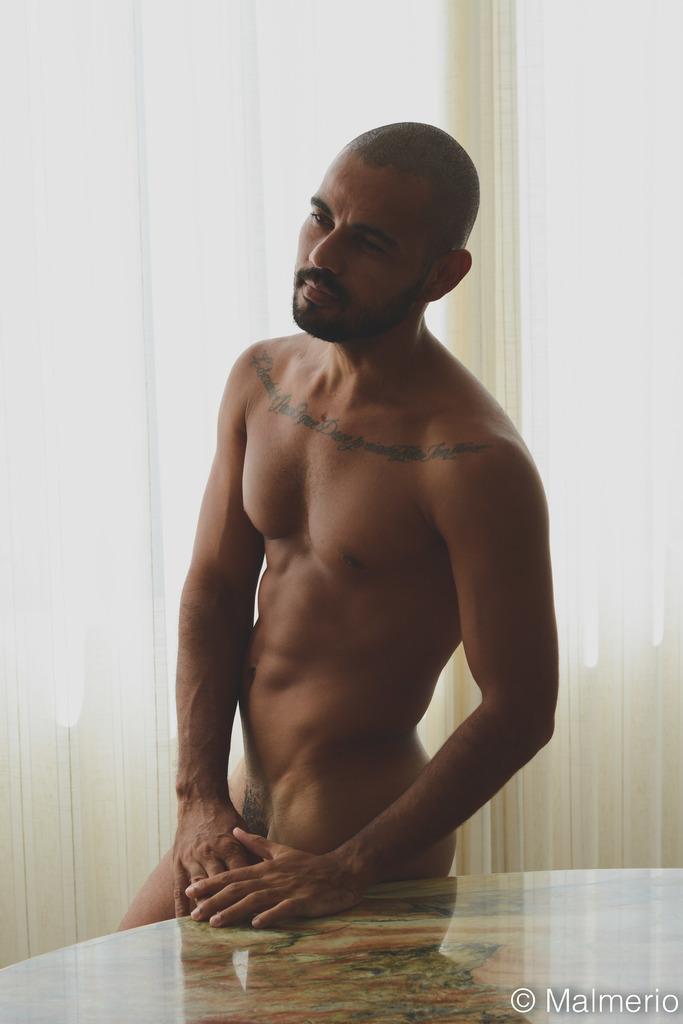Describe this image in one or two sentences. In this image I see man who is naked and I see the table over here and I see the watermark over here and it is white in the background. 